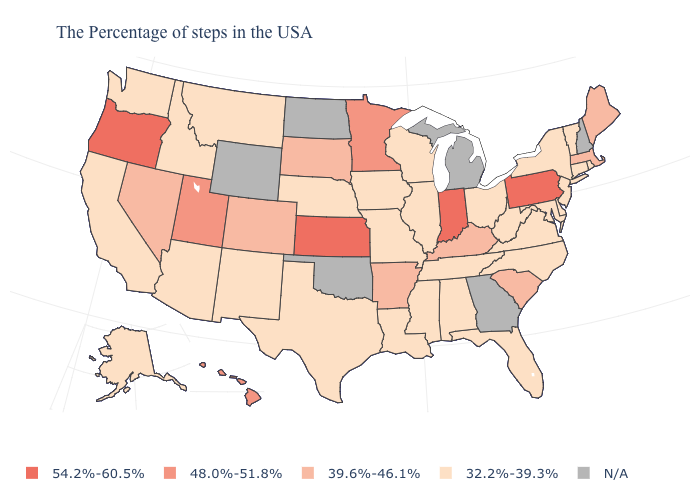Name the states that have a value in the range 54.2%-60.5%?
Keep it brief. Pennsylvania, Indiana, Kansas, Oregon. What is the value of Georgia?
Answer briefly. N/A. Name the states that have a value in the range N/A?
Concise answer only. New Hampshire, Georgia, Michigan, Oklahoma, North Dakota, Wyoming. Is the legend a continuous bar?
Be succinct. No. Name the states that have a value in the range 32.2%-39.3%?
Answer briefly. Rhode Island, Vermont, Connecticut, New York, New Jersey, Delaware, Maryland, Virginia, North Carolina, West Virginia, Ohio, Florida, Alabama, Tennessee, Wisconsin, Illinois, Mississippi, Louisiana, Missouri, Iowa, Nebraska, Texas, New Mexico, Montana, Arizona, Idaho, California, Washington, Alaska. Among the states that border Utah , does New Mexico have the lowest value?
Quick response, please. Yes. Which states have the lowest value in the USA?
Be succinct. Rhode Island, Vermont, Connecticut, New York, New Jersey, Delaware, Maryland, Virginia, North Carolina, West Virginia, Ohio, Florida, Alabama, Tennessee, Wisconsin, Illinois, Mississippi, Louisiana, Missouri, Iowa, Nebraska, Texas, New Mexico, Montana, Arizona, Idaho, California, Washington, Alaska. Name the states that have a value in the range N/A?
Quick response, please. New Hampshire, Georgia, Michigan, Oklahoma, North Dakota, Wyoming. What is the value of Montana?
Write a very short answer. 32.2%-39.3%. What is the value of California?
Be succinct. 32.2%-39.3%. Which states have the lowest value in the MidWest?
Be succinct. Ohio, Wisconsin, Illinois, Missouri, Iowa, Nebraska. What is the value of Florida?
Give a very brief answer. 32.2%-39.3%. Name the states that have a value in the range 32.2%-39.3%?
Concise answer only. Rhode Island, Vermont, Connecticut, New York, New Jersey, Delaware, Maryland, Virginia, North Carolina, West Virginia, Ohio, Florida, Alabama, Tennessee, Wisconsin, Illinois, Mississippi, Louisiana, Missouri, Iowa, Nebraska, Texas, New Mexico, Montana, Arizona, Idaho, California, Washington, Alaska. Does the first symbol in the legend represent the smallest category?
Keep it brief. No. What is the lowest value in the West?
Write a very short answer. 32.2%-39.3%. 